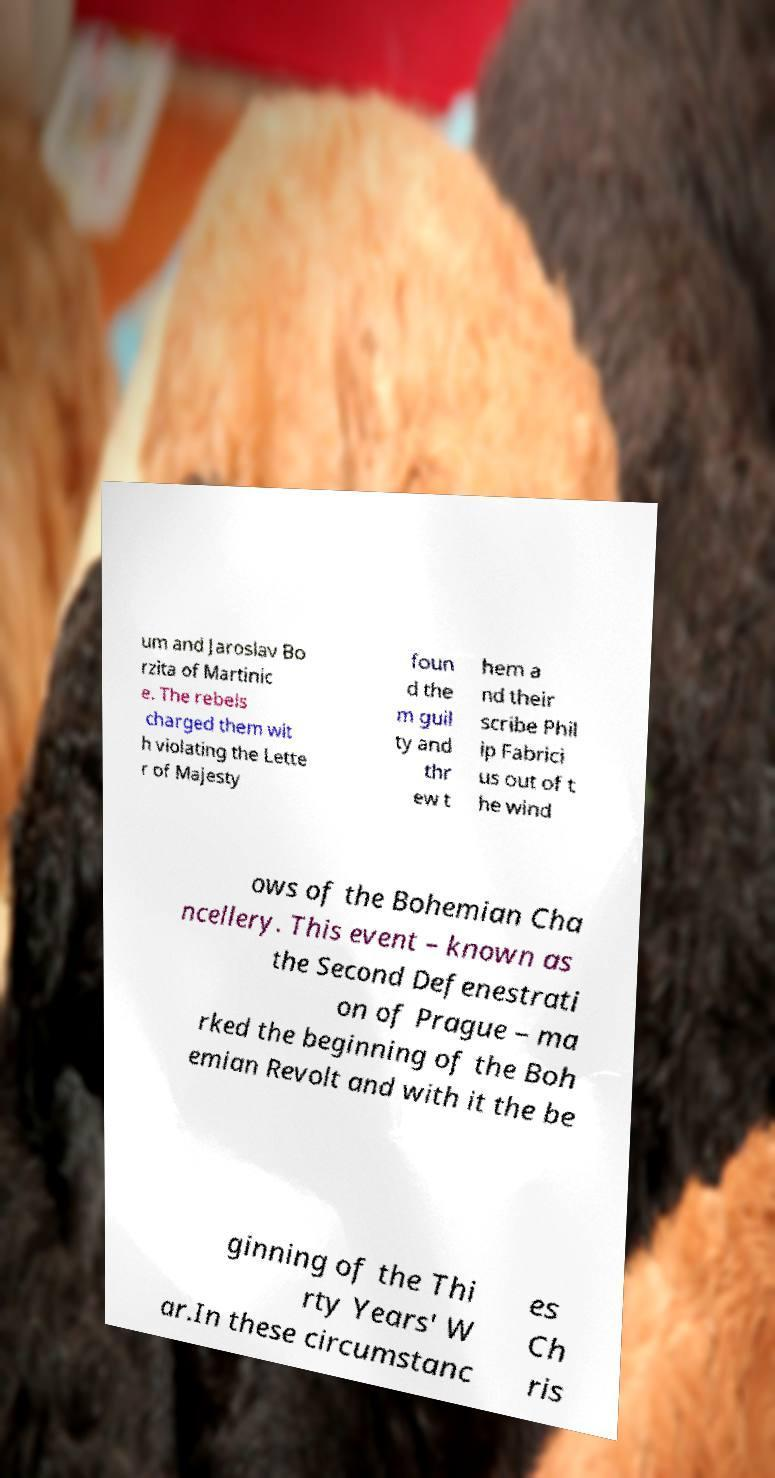Can you accurately transcribe the text from the provided image for me? um and Jaroslav Bo rzita of Martinic e. The rebels charged them wit h violating the Lette r of Majesty foun d the m guil ty and thr ew t hem a nd their scribe Phil ip Fabrici us out of t he wind ows of the Bohemian Cha ncellery. This event – known as the Second Defenestrati on of Prague – ma rked the beginning of the Boh emian Revolt and with it the be ginning of the Thi rty Years' W ar.In these circumstanc es Ch ris 